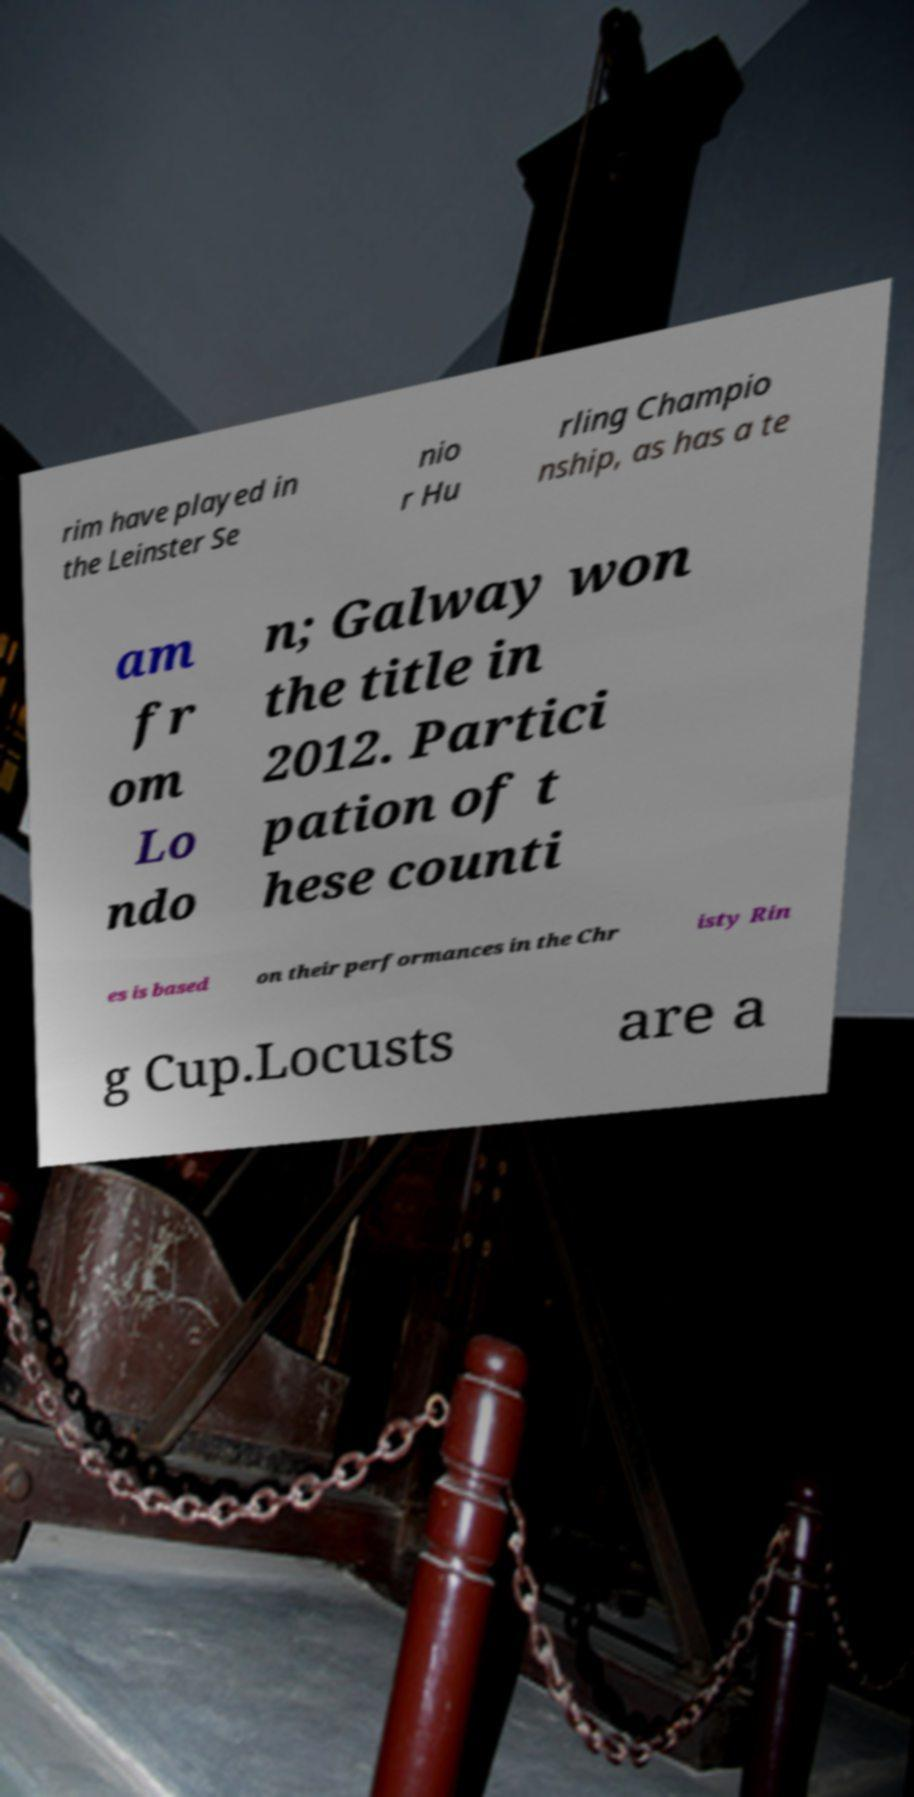For documentation purposes, I need the text within this image transcribed. Could you provide that? rim have played in the Leinster Se nio r Hu rling Champio nship, as has a te am fr om Lo ndo n; Galway won the title in 2012. Partici pation of t hese counti es is based on their performances in the Chr isty Rin g Cup.Locusts are a 